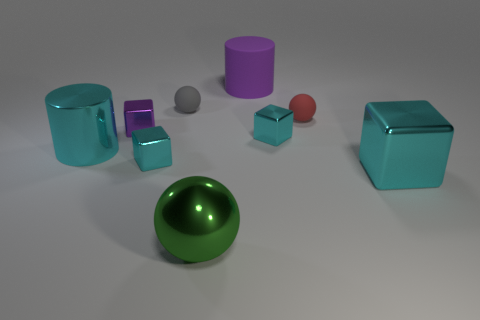What might be the texture of the surfaces visible in the image? The surfaces of the objects in the image have a glossy, smooth texture, indicative of a metallic or polished material. The reflections and highlights emphasize their shiny appearance, enhancing the perception of a smooth texture. 